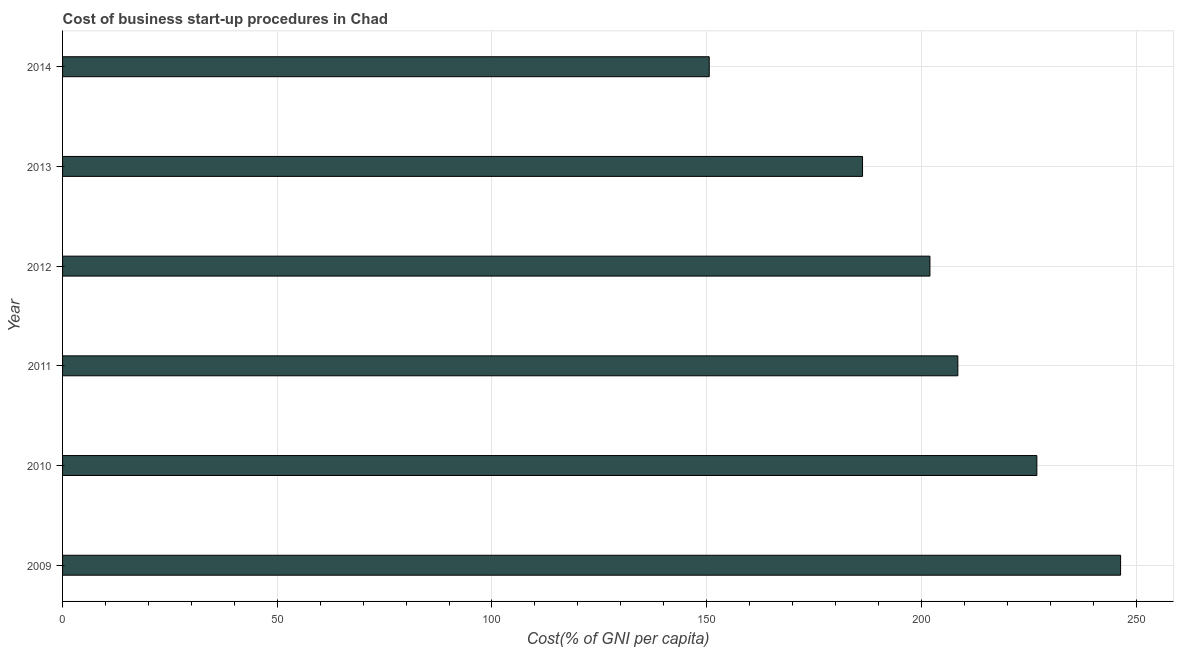Does the graph contain any zero values?
Give a very brief answer. No. What is the title of the graph?
Make the answer very short. Cost of business start-up procedures in Chad. What is the label or title of the X-axis?
Ensure brevity in your answer.  Cost(% of GNI per capita). What is the label or title of the Y-axis?
Provide a short and direct response. Year. What is the cost of business startup procedures in 2012?
Provide a short and direct response. 202. Across all years, what is the maximum cost of business startup procedures?
Offer a very short reply. 246.4. Across all years, what is the minimum cost of business startup procedures?
Your answer should be compact. 150.6. In which year was the cost of business startup procedures minimum?
Give a very brief answer. 2014. What is the sum of the cost of business startup procedures?
Provide a succinct answer. 1220.7. What is the difference between the cost of business startup procedures in 2009 and 2014?
Ensure brevity in your answer.  95.8. What is the average cost of business startup procedures per year?
Give a very brief answer. 203.45. What is the median cost of business startup procedures?
Give a very brief answer. 205.25. In how many years, is the cost of business startup procedures greater than 10 %?
Your answer should be compact. 6. What is the ratio of the cost of business startup procedures in 2010 to that in 2011?
Provide a short and direct response. 1.09. Is the cost of business startup procedures in 2011 less than that in 2013?
Keep it short and to the point. No. What is the difference between the highest and the second highest cost of business startup procedures?
Offer a terse response. 19.5. Is the sum of the cost of business startup procedures in 2009 and 2013 greater than the maximum cost of business startup procedures across all years?
Give a very brief answer. Yes. What is the difference between the highest and the lowest cost of business startup procedures?
Ensure brevity in your answer.  95.8. In how many years, is the cost of business startup procedures greater than the average cost of business startup procedures taken over all years?
Provide a succinct answer. 3. How many bars are there?
Your answer should be compact. 6. Are all the bars in the graph horizontal?
Ensure brevity in your answer.  Yes. How many years are there in the graph?
Provide a short and direct response. 6. Are the values on the major ticks of X-axis written in scientific E-notation?
Keep it short and to the point. No. What is the Cost(% of GNI per capita) of 2009?
Ensure brevity in your answer.  246.4. What is the Cost(% of GNI per capita) in 2010?
Keep it short and to the point. 226.9. What is the Cost(% of GNI per capita) of 2011?
Make the answer very short. 208.5. What is the Cost(% of GNI per capita) in 2012?
Offer a terse response. 202. What is the Cost(% of GNI per capita) of 2013?
Your answer should be very brief. 186.3. What is the Cost(% of GNI per capita) of 2014?
Make the answer very short. 150.6. What is the difference between the Cost(% of GNI per capita) in 2009 and 2010?
Provide a short and direct response. 19.5. What is the difference between the Cost(% of GNI per capita) in 2009 and 2011?
Offer a very short reply. 37.9. What is the difference between the Cost(% of GNI per capita) in 2009 and 2012?
Provide a short and direct response. 44.4. What is the difference between the Cost(% of GNI per capita) in 2009 and 2013?
Make the answer very short. 60.1. What is the difference between the Cost(% of GNI per capita) in 2009 and 2014?
Make the answer very short. 95.8. What is the difference between the Cost(% of GNI per capita) in 2010 and 2012?
Ensure brevity in your answer.  24.9. What is the difference between the Cost(% of GNI per capita) in 2010 and 2013?
Offer a very short reply. 40.6. What is the difference between the Cost(% of GNI per capita) in 2010 and 2014?
Provide a short and direct response. 76.3. What is the difference between the Cost(% of GNI per capita) in 2011 and 2012?
Offer a terse response. 6.5. What is the difference between the Cost(% of GNI per capita) in 2011 and 2013?
Your answer should be compact. 22.2. What is the difference between the Cost(% of GNI per capita) in 2011 and 2014?
Keep it short and to the point. 57.9. What is the difference between the Cost(% of GNI per capita) in 2012 and 2014?
Your answer should be compact. 51.4. What is the difference between the Cost(% of GNI per capita) in 2013 and 2014?
Provide a short and direct response. 35.7. What is the ratio of the Cost(% of GNI per capita) in 2009 to that in 2010?
Offer a terse response. 1.09. What is the ratio of the Cost(% of GNI per capita) in 2009 to that in 2011?
Provide a succinct answer. 1.18. What is the ratio of the Cost(% of GNI per capita) in 2009 to that in 2012?
Provide a short and direct response. 1.22. What is the ratio of the Cost(% of GNI per capita) in 2009 to that in 2013?
Your answer should be very brief. 1.32. What is the ratio of the Cost(% of GNI per capita) in 2009 to that in 2014?
Your answer should be compact. 1.64. What is the ratio of the Cost(% of GNI per capita) in 2010 to that in 2011?
Provide a succinct answer. 1.09. What is the ratio of the Cost(% of GNI per capita) in 2010 to that in 2012?
Keep it short and to the point. 1.12. What is the ratio of the Cost(% of GNI per capita) in 2010 to that in 2013?
Your answer should be very brief. 1.22. What is the ratio of the Cost(% of GNI per capita) in 2010 to that in 2014?
Your answer should be very brief. 1.51. What is the ratio of the Cost(% of GNI per capita) in 2011 to that in 2012?
Offer a terse response. 1.03. What is the ratio of the Cost(% of GNI per capita) in 2011 to that in 2013?
Ensure brevity in your answer.  1.12. What is the ratio of the Cost(% of GNI per capita) in 2011 to that in 2014?
Give a very brief answer. 1.38. What is the ratio of the Cost(% of GNI per capita) in 2012 to that in 2013?
Your answer should be compact. 1.08. What is the ratio of the Cost(% of GNI per capita) in 2012 to that in 2014?
Your answer should be very brief. 1.34. What is the ratio of the Cost(% of GNI per capita) in 2013 to that in 2014?
Make the answer very short. 1.24. 